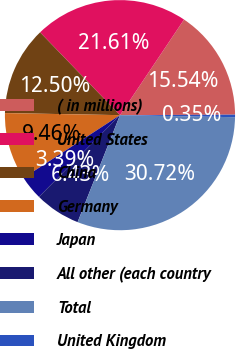Convert chart to OTSL. <chart><loc_0><loc_0><loc_500><loc_500><pie_chart><fcel>( in millions)<fcel>United States<fcel>China<fcel>Germany<fcel>Japan<fcel>All other (each country<fcel>Total<fcel>United Kingdom<nl><fcel>15.54%<fcel>21.61%<fcel>12.5%<fcel>9.46%<fcel>3.39%<fcel>6.43%<fcel>30.72%<fcel>0.35%<nl></chart> 